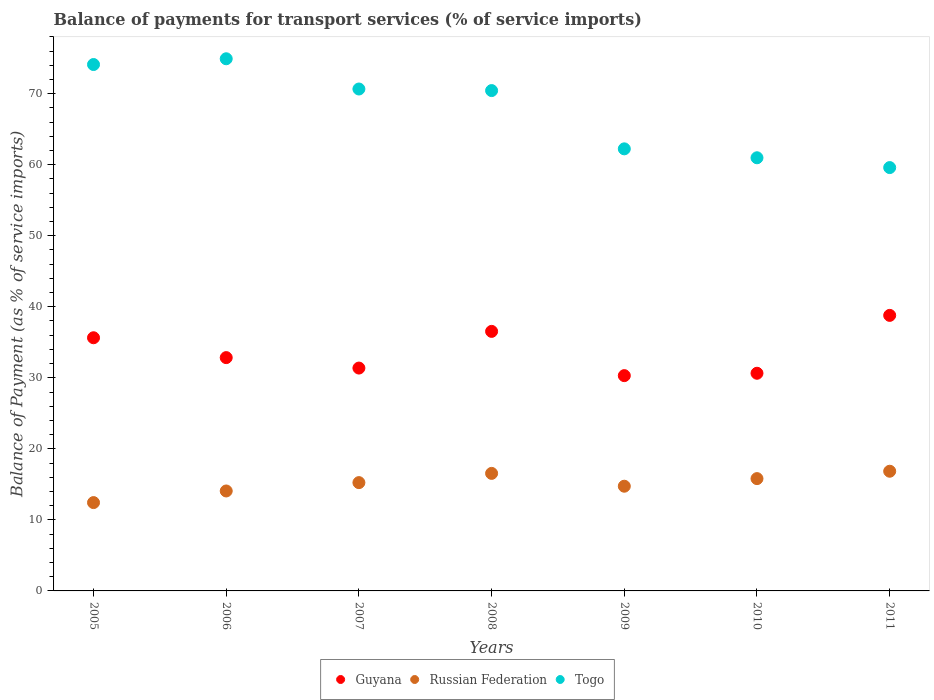How many different coloured dotlines are there?
Ensure brevity in your answer.  3. What is the balance of payments for transport services in Russian Federation in 2005?
Keep it short and to the point. 12.43. Across all years, what is the maximum balance of payments for transport services in Russian Federation?
Your response must be concise. 16.85. Across all years, what is the minimum balance of payments for transport services in Guyana?
Give a very brief answer. 30.31. What is the total balance of payments for transport services in Guyana in the graph?
Provide a succinct answer. 236.12. What is the difference between the balance of payments for transport services in Togo in 2008 and that in 2010?
Offer a very short reply. 9.46. What is the difference between the balance of payments for transport services in Russian Federation in 2006 and the balance of payments for transport services in Guyana in 2007?
Ensure brevity in your answer.  -17.3. What is the average balance of payments for transport services in Guyana per year?
Provide a short and direct response. 33.73. In the year 2006, what is the difference between the balance of payments for transport services in Russian Federation and balance of payments for transport services in Guyana?
Keep it short and to the point. -18.77. What is the ratio of the balance of payments for transport services in Togo in 2005 to that in 2008?
Your answer should be very brief. 1.05. What is the difference between the highest and the second highest balance of payments for transport services in Russian Federation?
Provide a short and direct response. 0.3. What is the difference between the highest and the lowest balance of payments for transport services in Guyana?
Offer a very short reply. 8.48. In how many years, is the balance of payments for transport services in Guyana greater than the average balance of payments for transport services in Guyana taken over all years?
Give a very brief answer. 3. Is the sum of the balance of payments for transport services in Russian Federation in 2007 and 2009 greater than the maximum balance of payments for transport services in Togo across all years?
Provide a succinct answer. No. Is the balance of payments for transport services in Togo strictly greater than the balance of payments for transport services in Russian Federation over the years?
Your answer should be very brief. Yes. What is the difference between two consecutive major ticks on the Y-axis?
Your response must be concise. 10. Does the graph contain grids?
Make the answer very short. No. Where does the legend appear in the graph?
Offer a terse response. Bottom center. How many legend labels are there?
Keep it short and to the point. 3. What is the title of the graph?
Provide a succinct answer. Balance of payments for transport services (% of service imports). Does "Togo" appear as one of the legend labels in the graph?
Your response must be concise. Yes. What is the label or title of the X-axis?
Ensure brevity in your answer.  Years. What is the label or title of the Y-axis?
Keep it short and to the point. Balance of Payment (as % of service imports). What is the Balance of Payment (as % of service imports) in Guyana in 2005?
Give a very brief answer. 35.64. What is the Balance of Payment (as % of service imports) in Russian Federation in 2005?
Provide a short and direct response. 12.43. What is the Balance of Payment (as % of service imports) in Togo in 2005?
Your answer should be compact. 74.1. What is the Balance of Payment (as % of service imports) of Guyana in 2006?
Keep it short and to the point. 32.84. What is the Balance of Payment (as % of service imports) of Russian Federation in 2006?
Your response must be concise. 14.07. What is the Balance of Payment (as % of service imports) in Togo in 2006?
Give a very brief answer. 74.91. What is the Balance of Payment (as % of service imports) in Guyana in 2007?
Your answer should be compact. 31.37. What is the Balance of Payment (as % of service imports) in Russian Federation in 2007?
Ensure brevity in your answer.  15.25. What is the Balance of Payment (as % of service imports) of Togo in 2007?
Keep it short and to the point. 70.65. What is the Balance of Payment (as % of service imports) of Guyana in 2008?
Provide a short and direct response. 36.53. What is the Balance of Payment (as % of service imports) of Russian Federation in 2008?
Offer a very short reply. 16.54. What is the Balance of Payment (as % of service imports) of Togo in 2008?
Offer a very short reply. 70.43. What is the Balance of Payment (as % of service imports) in Guyana in 2009?
Ensure brevity in your answer.  30.31. What is the Balance of Payment (as % of service imports) in Russian Federation in 2009?
Offer a very short reply. 14.74. What is the Balance of Payment (as % of service imports) of Togo in 2009?
Give a very brief answer. 62.23. What is the Balance of Payment (as % of service imports) of Guyana in 2010?
Provide a succinct answer. 30.64. What is the Balance of Payment (as % of service imports) of Russian Federation in 2010?
Give a very brief answer. 15.81. What is the Balance of Payment (as % of service imports) of Togo in 2010?
Provide a short and direct response. 60.97. What is the Balance of Payment (as % of service imports) in Guyana in 2011?
Offer a terse response. 38.79. What is the Balance of Payment (as % of service imports) in Russian Federation in 2011?
Provide a succinct answer. 16.85. What is the Balance of Payment (as % of service imports) in Togo in 2011?
Provide a succinct answer. 59.59. Across all years, what is the maximum Balance of Payment (as % of service imports) in Guyana?
Offer a terse response. 38.79. Across all years, what is the maximum Balance of Payment (as % of service imports) of Russian Federation?
Provide a succinct answer. 16.85. Across all years, what is the maximum Balance of Payment (as % of service imports) in Togo?
Ensure brevity in your answer.  74.91. Across all years, what is the minimum Balance of Payment (as % of service imports) of Guyana?
Ensure brevity in your answer.  30.31. Across all years, what is the minimum Balance of Payment (as % of service imports) in Russian Federation?
Ensure brevity in your answer.  12.43. Across all years, what is the minimum Balance of Payment (as % of service imports) in Togo?
Keep it short and to the point. 59.59. What is the total Balance of Payment (as % of service imports) of Guyana in the graph?
Keep it short and to the point. 236.12. What is the total Balance of Payment (as % of service imports) in Russian Federation in the graph?
Provide a succinct answer. 105.69. What is the total Balance of Payment (as % of service imports) in Togo in the graph?
Your response must be concise. 472.89. What is the difference between the Balance of Payment (as % of service imports) in Guyana in 2005 and that in 2006?
Give a very brief answer. 2.8. What is the difference between the Balance of Payment (as % of service imports) in Russian Federation in 2005 and that in 2006?
Provide a short and direct response. -1.64. What is the difference between the Balance of Payment (as % of service imports) of Togo in 2005 and that in 2006?
Your answer should be compact. -0.81. What is the difference between the Balance of Payment (as % of service imports) of Guyana in 2005 and that in 2007?
Your answer should be very brief. 4.27. What is the difference between the Balance of Payment (as % of service imports) of Russian Federation in 2005 and that in 2007?
Offer a terse response. -2.81. What is the difference between the Balance of Payment (as % of service imports) in Togo in 2005 and that in 2007?
Your answer should be very brief. 3.45. What is the difference between the Balance of Payment (as % of service imports) of Guyana in 2005 and that in 2008?
Your response must be concise. -0.9. What is the difference between the Balance of Payment (as % of service imports) of Russian Federation in 2005 and that in 2008?
Provide a succinct answer. -4.11. What is the difference between the Balance of Payment (as % of service imports) in Togo in 2005 and that in 2008?
Ensure brevity in your answer.  3.67. What is the difference between the Balance of Payment (as % of service imports) in Guyana in 2005 and that in 2009?
Give a very brief answer. 5.33. What is the difference between the Balance of Payment (as % of service imports) in Russian Federation in 2005 and that in 2009?
Provide a short and direct response. -2.31. What is the difference between the Balance of Payment (as % of service imports) of Togo in 2005 and that in 2009?
Provide a succinct answer. 11.87. What is the difference between the Balance of Payment (as % of service imports) in Guyana in 2005 and that in 2010?
Provide a short and direct response. 5. What is the difference between the Balance of Payment (as % of service imports) of Russian Federation in 2005 and that in 2010?
Make the answer very short. -3.38. What is the difference between the Balance of Payment (as % of service imports) in Togo in 2005 and that in 2010?
Give a very brief answer. 13.13. What is the difference between the Balance of Payment (as % of service imports) in Guyana in 2005 and that in 2011?
Offer a terse response. -3.15. What is the difference between the Balance of Payment (as % of service imports) in Russian Federation in 2005 and that in 2011?
Make the answer very short. -4.41. What is the difference between the Balance of Payment (as % of service imports) of Togo in 2005 and that in 2011?
Your answer should be compact. 14.51. What is the difference between the Balance of Payment (as % of service imports) in Guyana in 2006 and that in 2007?
Your answer should be very brief. 1.47. What is the difference between the Balance of Payment (as % of service imports) in Russian Federation in 2006 and that in 2007?
Offer a terse response. -1.18. What is the difference between the Balance of Payment (as % of service imports) in Togo in 2006 and that in 2007?
Provide a succinct answer. 4.26. What is the difference between the Balance of Payment (as % of service imports) in Guyana in 2006 and that in 2008?
Offer a very short reply. -3.69. What is the difference between the Balance of Payment (as % of service imports) in Russian Federation in 2006 and that in 2008?
Your response must be concise. -2.47. What is the difference between the Balance of Payment (as % of service imports) in Togo in 2006 and that in 2008?
Give a very brief answer. 4.48. What is the difference between the Balance of Payment (as % of service imports) of Guyana in 2006 and that in 2009?
Offer a terse response. 2.54. What is the difference between the Balance of Payment (as % of service imports) of Russian Federation in 2006 and that in 2009?
Offer a terse response. -0.67. What is the difference between the Balance of Payment (as % of service imports) in Togo in 2006 and that in 2009?
Your answer should be compact. 12.68. What is the difference between the Balance of Payment (as % of service imports) in Guyana in 2006 and that in 2010?
Keep it short and to the point. 2.2. What is the difference between the Balance of Payment (as % of service imports) of Russian Federation in 2006 and that in 2010?
Give a very brief answer. -1.74. What is the difference between the Balance of Payment (as % of service imports) of Togo in 2006 and that in 2010?
Give a very brief answer. 13.94. What is the difference between the Balance of Payment (as % of service imports) in Guyana in 2006 and that in 2011?
Your answer should be compact. -5.95. What is the difference between the Balance of Payment (as % of service imports) in Russian Federation in 2006 and that in 2011?
Your answer should be very brief. -2.78. What is the difference between the Balance of Payment (as % of service imports) of Togo in 2006 and that in 2011?
Offer a terse response. 15.32. What is the difference between the Balance of Payment (as % of service imports) of Guyana in 2007 and that in 2008?
Make the answer very short. -5.16. What is the difference between the Balance of Payment (as % of service imports) in Russian Federation in 2007 and that in 2008?
Keep it short and to the point. -1.3. What is the difference between the Balance of Payment (as % of service imports) of Togo in 2007 and that in 2008?
Give a very brief answer. 0.22. What is the difference between the Balance of Payment (as % of service imports) in Guyana in 2007 and that in 2009?
Your answer should be compact. 1.07. What is the difference between the Balance of Payment (as % of service imports) of Russian Federation in 2007 and that in 2009?
Give a very brief answer. 0.51. What is the difference between the Balance of Payment (as % of service imports) of Togo in 2007 and that in 2009?
Your answer should be very brief. 8.42. What is the difference between the Balance of Payment (as % of service imports) in Guyana in 2007 and that in 2010?
Your response must be concise. 0.73. What is the difference between the Balance of Payment (as % of service imports) in Russian Federation in 2007 and that in 2010?
Provide a succinct answer. -0.56. What is the difference between the Balance of Payment (as % of service imports) in Togo in 2007 and that in 2010?
Give a very brief answer. 9.68. What is the difference between the Balance of Payment (as % of service imports) in Guyana in 2007 and that in 2011?
Make the answer very short. -7.42. What is the difference between the Balance of Payment (as % of service imports) in Russian Federation in 2007 and that in 2011?
Keep it short and to the point. -1.6. What is the difference between the Balance of Payment (as % of service imports) in Togo in 2007 and that in 2011?
Your answer should be very brief. 11.06. What is the difference between the Balance of Payment (as % of service imports) in Guyana in 2008 and that in 2009?
Offer a terse response. 6.23. What is the difference between the Balance of Payment (as % of service imports) of Russian Federation in 2008 and that in 2009?
Make the answer very short. 1.81. What is the difference between the Balance of Payment (as % of service imports) of Togo in 2008 and that in 2009?
Give a very brief answer. 8.2. What is the difference between the Balance of Payment (as % of service imports) in Guyana in 2008 and that in 2010?
Keep it short and to the point. 5.89. What is the difference between the Balance of Payment (as % of service imports) of Russian Federation in 2008 and that in 2010?
Provide a succinct answer. 0.74. What is the difference between the Balance of Payment (as % of service imports) in Togo in 2008 and that in 2010?
Your response must be concise. 9.46. What is the difference between the Balance of Payment (as % of service imports) of Guyana in 2008 and that in 2011?
Your answer should be compact. -2.25. What is the difference between the Balance of Payment (as % of service imports) of Russian Federation in 2008 and that in 2011?
Keep it short and to the point. -0.3. What is the difference between the Balance of Payment (as % of service imports) of Togo in 2008 and that in 2011?
Your answer should be very brief. 10.84. What is the difference between the Balance of Payment (as % of service imports) of Guyana in 2009 and that in 2010?
Your answer should be very brief. -0.33. What is the difference between the Balance of Payment (as % of service imports) of Russian Federation in 2009 and that in 2010?
Your response must be concise. -1.07. What is the difference between the Balance of Payment (as % of service imports) of Togo in 2009 and that in 2010?
Your answer should be very brief. 1.26. What is the difference between the Balance of Payment (as % of service imports) of Guyana in 2009 and that in 2011?
Make the answer very short. -8.48. What is the difference between the Balance of Payment (as % of service imports) of Russian Federation in 2009 and that in 2011?
Your answer should be very brief. -2.11. What is the difference between the Balance of Payment (as % of service imports) of Togo in 2009 and that in 2011?
Provide a short and direct response. 2.64. What is the difference between the Balance of Payment (as % of service imports) in Guyana in 2010 and that in 2011?
Offer a very short reply. -8.15. What is the difference between the Balance of Payment (as % of service imports) of Russian Federation in 2010 and that in 2011?
Ensure brevity in your answer.  -1.04. What is the difference between the Balance of Payment (as % of service imports) of Togo in 2010 and that in 2011?
Your response must be concise. 1.38. What is the difference between the Balance of Payment (as % of service imports) in Guyana in 2005 and the Balance of Payment (as % of service imports) in Russian Federation in 2006?
Your answer should be compact. 21.57. What is the difference between the Balance of Payment (as % of service imports) of Guyana in 2005 and the Balance of Payment (as % of service imports) of Togo in 2006?
Provide a short and direct response. -39.27. What is the difference between the Balance of Payment (as % of service imports) of Russian Federation in 2005 and the Balance of Payment (as % of service imports) of Togo in 2006?
Provide a succinct answer. -62.48. What is the difference between the Balance of Payment (as % of service imports) in Guyana in 2005 and the Balance of Payment (as % of service imports) in Russian Federation in 2007?
Ensure brevity in your answer.  20.39. What is the difference between the Balance of Payment (as % of service imports) in Guyana in 2005 and the Balance of Payment (as % of service imports) in Togo in 2007?
Provide a succinct answer. -35.02. What is the difference between the Balance of Payment (as % of service imports) in Russian Federation in 2005 and the Balance of Payment (as % of service imports) in Togo in 2007?
Your response must be concise. -58.22. What is the difference between the Balance of Payment (as % of service imports) of Guyana in 2005 and the Balance of Payment (as % of service imports) of Russian Federation in 2008?
Provide a short and direct response. 19.09. What is the difference between the Balance of Payment (as % of service imports) in Guyana in 2005 and the Balance of Payment (as % of service imports) in Togo in 2008?
Offer a very short reply. -34.79. What is the difference between the Balance of Payment (as % of service imports) of Russian Federation in 2005 and the Balance of Payment (as % of service imports) of Togo in 2008?
Offer a very short reply. -58. What is the difference between the Balance of Payment (as % of service imports) of Guyana in 2005 and the Balance of Payment (as % of service imports) of Russian Federation in 2009?
Ensure brevity in your answer.  20.9. What is the difference between the Balance of Payment (as % of service imports) in Guyana in 2005 and the Balance of Payment (as % of service imports) in Togo in 2009?
Ensure brevity in your answer.  -26.59. What is the difference between the Balance of Payment (as % of service imports) of Russian Federation in 2005 and the Balance of Payment (as % of service imports) of Togo in 2009?
Offer a terse response. -49.8. What is the difference between the Balance of Payment (as % of service imports) in Guyana in 2005 and the Balance of Payment (as % of service imports) in Russian Federation in 2010?
Keep it short and to the point. 19.83. What is the difference between the Balance of Payment (as % of service imports) of Guyana in 2005 and the Balance of Payment (as % of service imports) of Togo in 2010?
Keep it short and to the point. -25.34. What is the difference between the Balance of Payment (as % of service imports) in Russian Federation in 2005 and the Balance of Payment (as % of service imports) in Togo in 2010?
Ensure brevity in your answer.  -48.54. What is the difference between the Balance of Payment (as % of service imports) of Guyana in 2005 and the Balance of Payment (as % of service imports) of Russian Federation in 2011?
Offer a terse response. 18.79. What is the difference between the Balance of Payment (as % of service imports) of Guyana in 2005 and the Balance of Payment (as % of service imports) of Togo in 2011?
Make the answer very short. -23.95. What is the difference between the Balance of Payment (as % of service imports) in Russian Federation in 2005 and the Balance of Payment (as % of service imports) in Togo in 2011?
Make the answer very short. -47.16. What is the difference between the Balance of Payment (as % of service imports) in Guyana in 2006 and the Balance of Payment (as % of service imports) in Russian Federation in 2007?
Your answer should be compact. 17.6. What is the difference between the Balance of Payment (as % of service imports) of Guyana in 2006 and the Balance of Payment (as % of service imports) of Togo in 2007?
Offer a terse response. -37.81. What is the difference between the Balance of Payment (as % of service imports) of Russian Federation in 2006 and the Balance of Payment (as % of service imports) of Togo in 2007?
Offer a very short reply. -56.58. What is the difference between the Balance of Payment (as % of service imports) in Guyana in 2006 and the Balance of Payment (as % of service imports) in Russian Federation in 2008?
Your answer should be very brief. 16.3. What is the difference between the Balance of Payment (as % of service imports) in Guyana in 2006 and the Balance of Payment (as % of service imports) in Togo in 2008?
Make the answer very short. -37.59. What is the difference between the Balance of Payment (as % of service imports) of Russian Federation in 2006 and the Balance of Payment (as % of service imports) of Togo in 2008?
Provide a short and direct response. -56.36. What is the difference between the Balance of Payment (as % of service imports) in Guyana in 2006 and the Balance of Payment (as % of service imports) in Russian Federation in 2009?
Provide a short and direct response. 18.1. What is the difference between the Balance of Payment (as % of service imports) in Guyana in 2006 and the Balance of Payment (as % of service imports) in Togo in 2009?
Your answer should be very brief. -29.39. What is the difference between the Balance of Payment (as % of service imports) of Russian Federation in 2006 and the Balance of Payment (as % of service imports) of Togo in 2009?
Ensure brevity in your answer.  -48.16. What is the difference between the Balance of Payment (as % of service imports) of Guyana in 2006 and the Balance of Payment (as % of service imports) of Russian Federation in 2010?
Keep it short and to the point. 17.03. What is the difference between the Balance of Payment (as % of service imports) of Guyana in 2006 and the Balance of Payment (as % of service imports) of Togo in 2010?
Your answer should be compact. -28.13. What is the difference between the Balance of Payment (as % of service imports) of Russian Federation in 2006 and the Balance of Payment (as % of service imports) of Togo in 2010?
Provide a short and direct response. -46.9. What is the difference between the Balance of Payment (as % of service imports) in Guyana in 2006 and the Balance of Payment (as % of service imports) in Russian Federation in 2011?
Provide a short and direct response. 15.99. What is the difference between the Balance of Payment (as % of service imports) in Guyana in 2006 and the Balance of Payment (as % of service imports) in Togo in 2011?
Provide a short and direct response. -26.75. What is the difference between the Balance of Payment (as % of service imports) in Russian Federation in 2006 and the Balance of Payment (as % of service imports) in Togo in 2011?
Give a very brief answer. -45.52. What is the difference between the Balance of Payment (as % of service imports) of Guyana in 2007 and the Balance of Payment (as % of service imports) of Russian Federation in 2008?
Make the answer very short. 14.83. What is the difference between the Balance of Payment (as % of service imports) of Guyana in 2007 and the Balance of Payment (as % of service imports) of Togo in 2008?
Offer a very short reply. -39.06. What is the difference between the Balance of Payment (as % of service imports) in Russian Federation in 2007 and the Balance of Payment (as % of service imports) in Togo in 2008?
Give a very brief answer. -55.19. What is the difference between the Balance of Payment (as % of service imports) in Guyana in 2007 and the Balance of Payment (as % of service imports) in Russian Federation in 2009?
Ensure brevity in your answer.  16.63. What is the difference between the Balance of Payment (as % of service imports) in Guyana in 2007 and the Balance of Payment (as % of service imports) in Togo in 2009?
Provide a succinct answer. -30.86. What is the difference between the Balance of Payment (as % of service imports) in Russian Federation in 2007 and the Balance of Payment (as % of service imports) in Togo in 2009?
Offer a terse response. -46.98. What is the difference between the Balance of Payment (as % of service imports) in Guyana in 2007 and the Balance of Payment (as % of service imports) in Russian Federation in 2010?
Offer a terse response. 15.56. What is the difference between the Balance of Payment (as % of service imports) in Guyana in 2007 and the Balance of Payment (as % of service imports) in Togo in 2010?
Ensure brevity in your answer.  -29.6. What is the difference between the Balance of Payment (as % of service imports) in Russian Federation in 2007 and the Balance of Payment (as % of service imports) in Togo in 2010?
Ensure brevity in your answer.  -45.73. What is the difference between the Balance of Payment (as % of service imports) of Guyana in 2007 and the Balance of Payment (as % of service imports) of Russian Federation in 2011?
Give a very brief answer. 14.52. What is the difference between the Balance of Payment (as % of service imports) in Guyana in 2007 and the Balance of Payment (as % of service imports) in Togo in 2011?
Offer a terse response. -28.22. What is the difference between the Balance of Payment (as % of service imports) of Russian Federation in 2007 and the Balance of Payment (as % of service imports) of Togo in 2011?
Give a very brief answer. -44.35. What is the difference between the Balance of Payment (as % of service imports) in Guyana in 2008 and the Balance of Payment (as % of service imports) in Russian Federation in 2009?
Offer a very short reply. 21.8. What is the difference between the Balance of Payment (as % of service imports) of Guyana in 2008 and the Balance of Payment (as % of service imports) of Togo in 2009?
Provide a succinct answer. -25.7. What is the difference between the Balance of Payment (as % of service imports) in Russian Federation in 2008 and the Balance of Payment (as % of service imports) in Togo in 2009?
Offer a very short reply. -45.69. What is the difference between the Balance of Payment (as % of service imports) of Guyana in 2008 and the Balance of Payment (as % of service imports) of Russian Federation in 2010?
Your answer should be very brief. 20.73. What is the difference between the Balance of Payment (as % of service imports) in Guyana in 2008 and the Balance of Payment (as % of service imports) in Togo in 2010?
Ensure brevity in your answer.  -24.44. What is the difference between the Balance of Payment (as % of service imports) in Russian Federation in 2008 and the Balance of Payment (as % of service imports) in Togo in 2010?
Offer a very short reply. -44.43. What is the difference between the Balance of Payment (as % of service imports) in Guyana in 2008 and the Balance of Payment (as % of service imports) in Russian Federation in 2011?
Offer a very short reply. 19.69. What is the difference between the Balance of Payment (as % of service imports) in Guyana in 2008 and the Balance of Payment (as % of service imports) in Togo in 2011?
Keep it short and to the point. -23.06. What is the difference between the Balance of Payment (as % of service imports) in Russian Federation in 2008 and the Balance of Payment (as % of service imports) in Togo in 2011?
Your answer should be compact. -43.05. What is the difference between the Balance of Payment (as % of service imports) of Guyana in 2009 and the Balance of Payment (as % of service imports) of Russian Federation in 2010?
Your answer should be compact. 14.5. What is the difference between the Balance of Payment (as % of service imports) of Guyana in 2009 and the Balance of Payment (as % of service imports) of Togo in 2010?
Your response must be concise. -30.67. What is the difference between the Balance of Payment (as % of service imports) in Russian Federation in 2009 and the Balance of Payment (as % of service imports) in Togo in 2010?
Provide a succinct answer. -46.23. What is the difference between the Balance of Payment (as % of service imports) of Guyana in 2009 and the Balance of Payment (as % of service imports) of Russian Federation in 2011?
Provide a short and direct response. 13.46. What is the difference between the Balance of Payment (as % of service imports) of Guyana in 2009 and the Balance of Payment (as % of service imports) of Togo in 2011?
Keep it short and to the point. -29.29. What is the difference between the Balance of Payment (as % of service imports) in Russian Federation in 2009 and the Balance of Payment (as % of service imports) in Togo in 2011?
Ensure brevity in your answer.  -44.85. What is the difference between the Balance of Payment (as % of service imports) of Guyana in 2010 and the Balance of Payment (as % of service imports) of Russian Federation in 2011?
Give a very brief answer. 13.79. What is the difference between the Balance of Payment (as % of service imports) in Guyana in 2010 and the Balance of Payment (as % of service imports) in Togo in 2011?
Offer a terse response. -28.95. What is the difference between the Balance of Payment (as % of service imports) of Russian Federation in 2010 and the Balance of Payment (as % of service imports) of Togo in 2011?
Provide a succinct answer. -43.78. What is the average Balance of Payment (as % of service imports) in Guyana per year?
Keep it short and to the point. 33.73. What is the average Balance of Payment (as % of service imports) of Russian Federation per year?
Give a very brief answer. 15.1. What is the average Balance of Payment (as % of service imports) in Togo per year?
Offer a terse response. 67.56. In the year 2005, what is the difference between the Balance of Payment (as % of service imports) in Guyana and Balance of Payment (as % of service imports) in Russian Federation?
Make the answer very short. 23.2. In the year 2005, what is the difference between the Balance of Payment (as % of service imports) of Guyana and Balance of Payment (as % of service imports) of Togo?
Provide a succinct answer. -38.46. In the year 2005, what is the difference between the Balance of Payment (as % of service imports) in Russian Federation and Balance of Payment (as % of service imports) in Togo?
Your response must be concise. -61.67. In the year 2006, what is the difference between the Balance of Payment (as % of service imports) of Guyana and Balance of Payment (as % of service imports) of Russian Federation?
Your response must be concise. 18.77. In the year 2006, what is the difference between the Balance of Payment (as % of service imports) in Guyana and Balance of Payment (as % of service imports) in Togo?
Your answer should be very brief. -42.07. In the year 2006, what is the difference between the Balance of Payment (as % of service imports) in Russian Federation and Balance of Payment (as % of service imports) in Togo?
Provide a succinct answer. -60.84. In the year 2007, what is the difference between the Balance of Payment (as % of service imports) in Guyana and Balance of Payment (as % of service imports) in Russian Federation?
Keep it short and to the point. 16.13. In the year 2007, what is the difference between the Balance of Payment (as % of service imports) of Guyana and Balance of Payment (as % of service imports) of Togo?
Make the answer very short. -39.28. In the year 2007, what is the difference between the Balance of Payment (as % of service imports) in Russian Federation and Balance of Payment (as % of service imports) in Togo?
Ensure brevity in your answer.  -55.41. In the year 2008, what is the difference between the Balance of Payment (as % of service imports) in Guyana and Balance of Payment (as % of service imports) in Russian Federation?
Offer a very short reply. 19.99. In the year 2008, what is the difference between the Balance of Payment (as % of service imports) of Guyana and Balance of Payment (as % of service imports) of Togo?
Your response must be concise. -33.9. In the year 2008, what is the difference between the Balance of Payment (as % of service imports) of Russian Federation and Balance of Payment (as % of service imports) of Togo?
Provide a succinct answer. -53.89. In the year 2009, what is the difference between the Balance of Payment (as % of service imports) of Guyana and Balance of Payment (as % of service imports) of Russian Federation?
Give a very brief answer. 15.57. In the year 2009, what is the difference between the Balance of Payment (as % of service imports) in Guyana and Balance of Payment (as % of service imports) in Togo?
Offer a very short reply. -31.92. In the year 2009, what is the difference between the Balance of Payment (as % of service imports) of Russian Federation and Balance of Payment (as % of service imports) of Togo?
Keep it short and to the point. -47.49. In the year 2010, what is the difference between the Balance of Payment (as % of service imports) of Guyana and Balance of Payment (as % of service imports) of Russian Federation?
Your response must be concise. 14.83. In the year 2010, what is the difference between the Balance of Payment (as % of service imports) in Guyana and Balance of Payment (as % of service imports) in Togo?
Provide a short and direct response. -30.33. In the year 2010, what is the difference between the Balance of Payment (as % of service imports) in Russian Federation and Balance of Payment (as % of service imports) in Togo?
Ensure brevity in your answer.  -45.16. In the year 2011, what is the difference between the Balance of Payment (as % of service imports) of Guyana and Balance of Payment (as % of service imports) of Russian Federation?
Offer a terse response. 21.94. In the year 2011, what is the difference between the Balance of Payment (as % of service imports) in Guyana and Balance of Payment (as % of service imports) in Togo?
Provide a succinct answer. -20.8. In the year 2011, what is the difference between the Balance of Payment (as % of service imports) in Russian Federation and Balance of Payment (as % of service imports) in Togo?
Provide a short and direct response. -42.74. What is the ratio of the Balance of Payment (as % of service imports) of Guyana in 2005 to that in 2006?
Your answer should be compact. 1.09. What is the ratio of the Balance of Payment (as % of service imports) of Russian Federation in 2005 to that in 2006?
Ensure brevity in your answer.  0.88. What is the ratio of the Balance of Payment (as % of service imports) of Togo in 2005 to that in 2006?
Your answer should be compact. 0.99. What is the ratio of the Balance of Payment (as % of service imports) in Guyana in 2005 to that in 2007?
Offer a very short reply. 1.14. What is the ratio of the Balance of Payment (as % of service imports) of Russian Federation in 2005 to that in 2007?
Your answer should be compact. 0.82. What is the ratio of the Balance of Payment (as % of service imports) in Togo in 2005 to that in 2007?
Offer a very short reply. 1.05. What is the ratio of the Balance of Payment (as % of service imports) of Guyana in 2005 to that in 2008?
Provide a succinct answer. 0.98. What is the ratio of the Balance of Payment (as % of service imports) in Russian Federation in 2005 to that in 2008?
Make the answer very short. 0.75. What is the ratio of the Balance of Payment (as % of service imports) of Togo in 2005 to that in 2008?
Your answer should be compact. 1.05. What is the ratio of the Balance of Payment (as % of service imports) of Guyana in 2005 to that in 2009?
Your answer should be compact. 1.18. What is the ratio of the Balance of Payment (as % of service imports) of Russian Federation in 2005 to that in 2009?
Your answer should be compact. 0.84. What is the ratio of the Balance of Payment (as % of service imports) of Togo in 2005 to that in 2009?
Your answer should be compact. 1.19. What is the ratio of the Balance of Payment (as % of service imports) in Guyana in 2005 to that in 2010?
Offer a very short reply. 1.16. What is the ratio of the Balance of Payment (as % of service imports) in Russian Federation in 2005 to that in 2010?
Your answer should be very brief. 0.79. What is the ratio of the Balance of Payment (as % of service imports) in Togo in 2005 to that in 2010?
Offer a terse response. 1.22. What is the ratio of the Balance of Payment (as % of service imports) of Guyana in 2005 to that in 2011?
Ensure brevity in your answer.  0.92. What is the ratio of the Balance of Payment (as % of service imports) of Russian Federation in 2005 to that in 2011?
Offer a very short reply. 0.74. What is the ratio of the Balance of Payment (as % of service imports) of Togo in 2005 to that in 2011?
Keep it short and to the point. 1.24. What is the ratio of the Balance of Payment (as % of service imports) of Guyana in 2006 to that in 2007?
Your answer should be compact. 1.05. What is the ratio of the Balance of Payment (as % of service imports) in Russian Federation in 2006 to that in 2007?
Provide a short and direct response. 0.92. What is the ratio of the Balance of Payment (as % of service imports) in Togo in 2006 to that in 2007?
Your answer should be very brief. 1.06. What is the ratio of the Balance of Payment (as % of service imports) of Guyana in 2006 to that in 2008?
Your answer should be compact. 0.9. What is the ratio of the Balance of Payment (as % of service imports) of Russian Federation in 2006 to that in 2008?
Keep it short and to the point. 0.85. What is the ratio of the Balance of Payment (as % of service imports) of Togo in 2006 to that in 2008?
Offer a terse response. 1.06. What is the ratio of the Balance of Payment (as % of service imports) of Guyana in 2006 to that in 2009?
Make the answer very short. 1.08. What is the ratio of the Balance of Payment (as % of service imports) of Russian Federation in 2006 to that in 2009?
Offer a very short reply. 0.95. What is the ratio of the Balance of Payment (as % of service imports) of Togo in 2006 to that in 2009?
Give a very brief answer. 1.2. What is the ratio of the Balance of Payment (as % of service imports) in Guyana in 2006 to that in 2010?
Offer a very short reply. 1.07. What is the ratio of the Balance of Payment (as % of service imports) of Russian Federation in 2006 to that in 2010?
Make the answer very short. 0.89. What is the ratio of the Balance of Payment (as % of service imports) of Togo in 2006 to that in 2010?
Offer a very short reply. 1.23. What is the ratio of the Balance of Payment (as % of service imports) of Guyana in 2006 to that in 2011?
Provide a succinct answer. 0.85. What is the ratio of the Balance of Payment (as % of service imports) in Russian Federation in 2006 to that in 2011?
Offer a very short reply. 0.84. What is the ratio of the Balance of Payment (as % of service imports) of Togo in 2006 to that in 2011?
Give a very brief answer. 1.26. What is the ratio of the Balance of Payment (as % of service imports) in Guyana in 2007 to that in 2008?
Keep it short and to the point. 0.86. What is the ratio of the Balance of Payment (as % of service imports) of Russian Federation in 2007 to that in 2008?
Make the answer very short. 0.92. What is the ratio of the Balance of Payment (as % of service imports) in Guyana in 2007 to that in 2009?
Your answer should be very brief. 1.04. What is the ratio of the Balance of Payment (as % of service imports) in Russian Federation in 2007 to that in 2009?
Give a very brief answer. 1.03. What is the ratio of the Balance of Payment (as % of service imports) in Togo in 2007 to that in 2009?
Provide a short and direct response. 1.14. What is the ratio of the Balance of Payment (as % of service imports) in Guyana in 2007 to that in 2010?
Provide a succinct answer. 1.02. What is the ratio of the Balance of Payment (as % of service imports) of Russian Federation in 2007 to that in 2010?
Make the answer very short. 0.96. What is the ratio of the Balance of Payment (as % of service imports) in Togo in 2007 to that in 2010?
Give a very brief answer. 1.16. What is the ratio of the Balance of Payment (as % of service imports) in Guyana in 2007 to that in 2011?
Your answer should be very brief. 0.81. What is the ratio of the Balance of Payment (as % of service imports) in Russian Federation in 2007 to that in 2011?
Ensure brevity in your answer.  0.9. What is the ratio of the Balance of Payment (as % of service imports) in Togo in 2007 to that in 2011?
Ensure brevity in your answer.  1.19. What is the ratio of the Balance of Payment (as % of service imports) of Guyana in 2008 to that in 2009?
Keep it short and to the point. 1.21. What is the ratio of the Balance of Payment (as % of service imports) in Russian Federation in 2008 to that in 2009?
Provide a short and direct response. 1.12. What is the ratio of the Balance of Payment (as % of service imports) in Togo in 2008 to that in 2009?
Your response must be concise. 1.13. What is the ratio of the Balance of Payment (as % of service imports) in Guyana in 2008 to that in 2010?
Your response must be concise. 1.19. What is the ratio of the Balance of Payment (as % of service imports) in Russian Federation in 2008 to that in 2010?
Your response must be concise. 1.05. What is the ratio of the Balance of Payment (as % of service imports) of Togo in 2008 to that in 2010?
Offer a terse response. 1.16. What is the ratio of the Balance of Payment (as % of service imports) of Guyana in 2008 to that in 2011?
Offer a very short reply. 0.94. What is the ratio of the Balance of Payment (as % of service imports) in Togo in 2008 to that in 2011?
Provide a succinct answer. 1.18. What is the ratio of the Balance of Payment (as % of service imports) in Russian Federation in 2009 to that in 2010?
Provide a succinct answer. 0.93. What is the ratio of the Balance of Payment (as % of service imports) in Togo in 2009 to that in 2010?
Provide a succinct answer. 1.02. What is the ratio of the Balance of Payment (as % of service imports) of Guyana in 2009 to that in 2011?
Make the answer very short. 0.78. What is the ratio of the Balance of Payment (as % of service imports) of Russian Federation in 2009 to that in 2011?
Your response must be concise. 0.87. What is the ratio of the Balance of Payment (as % of service imports) in Togo in 2009 to that in 2011?
Ensure brevity in your answer.  1.04. What is the ratio of the Balance of Payment (as % of service imports) in Guyana in 2010 to that in 2011?
Your answer should be compact. 0.79. What is the ratio of the Balance of Payment (as % of service imports) of Russian Federation in 2010 to that in 2011?
Provide a short and direct response. 0.94. What is the ratio of the Balance of Payment (as % of service imports) in Togo in 2010 to that in 2011?
Ensure brevity in your answer.  1.02. What is the difference between the highest and the second highest Balance of Payment (as % of service imports) of Guyana?
Your answer should be very brief. 2.25. What is the difference between the highest and the second highest Balance of Payment (as % of service imports) of Russian Federation?
Give a very brief answer. 0.3. What is the difference between the highest and the second highest Balance of Payment (as % of service imports) of Togo?
Make the answer very short. 0.81. What is the difference between the highest and the lowest Balance of Payment (as % of service imports) in Guyana?
Your answer should be compact. 8.48. What is the difference between the highest and the lowest Balance of Payment (as % of service imports) in Russian Federation?
Your answer should be very brief. 4.41. What is the difference between the highest and the lowest Balance of Payment (as % of service imports) of Togo?
Your answer should be very brief. 15.32. 